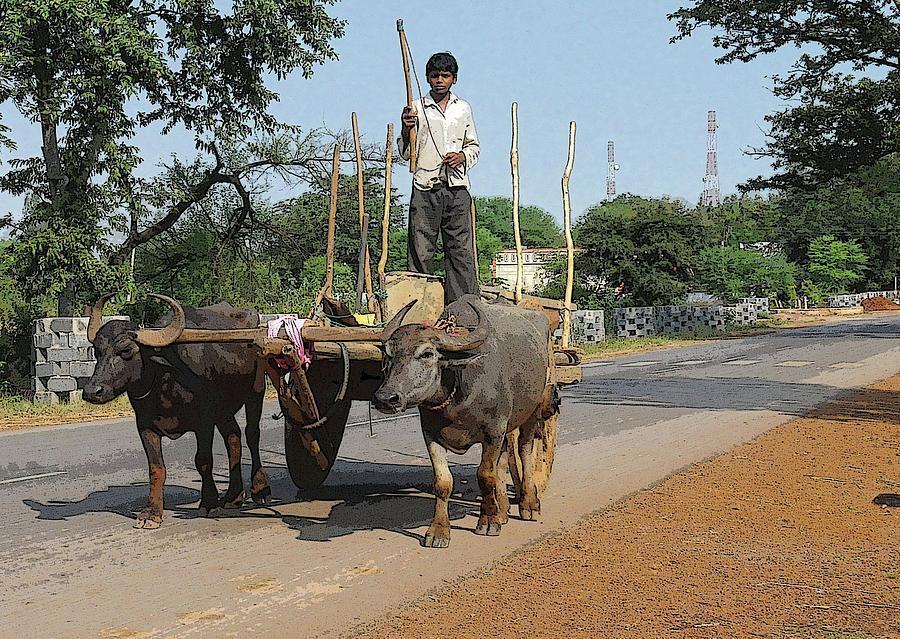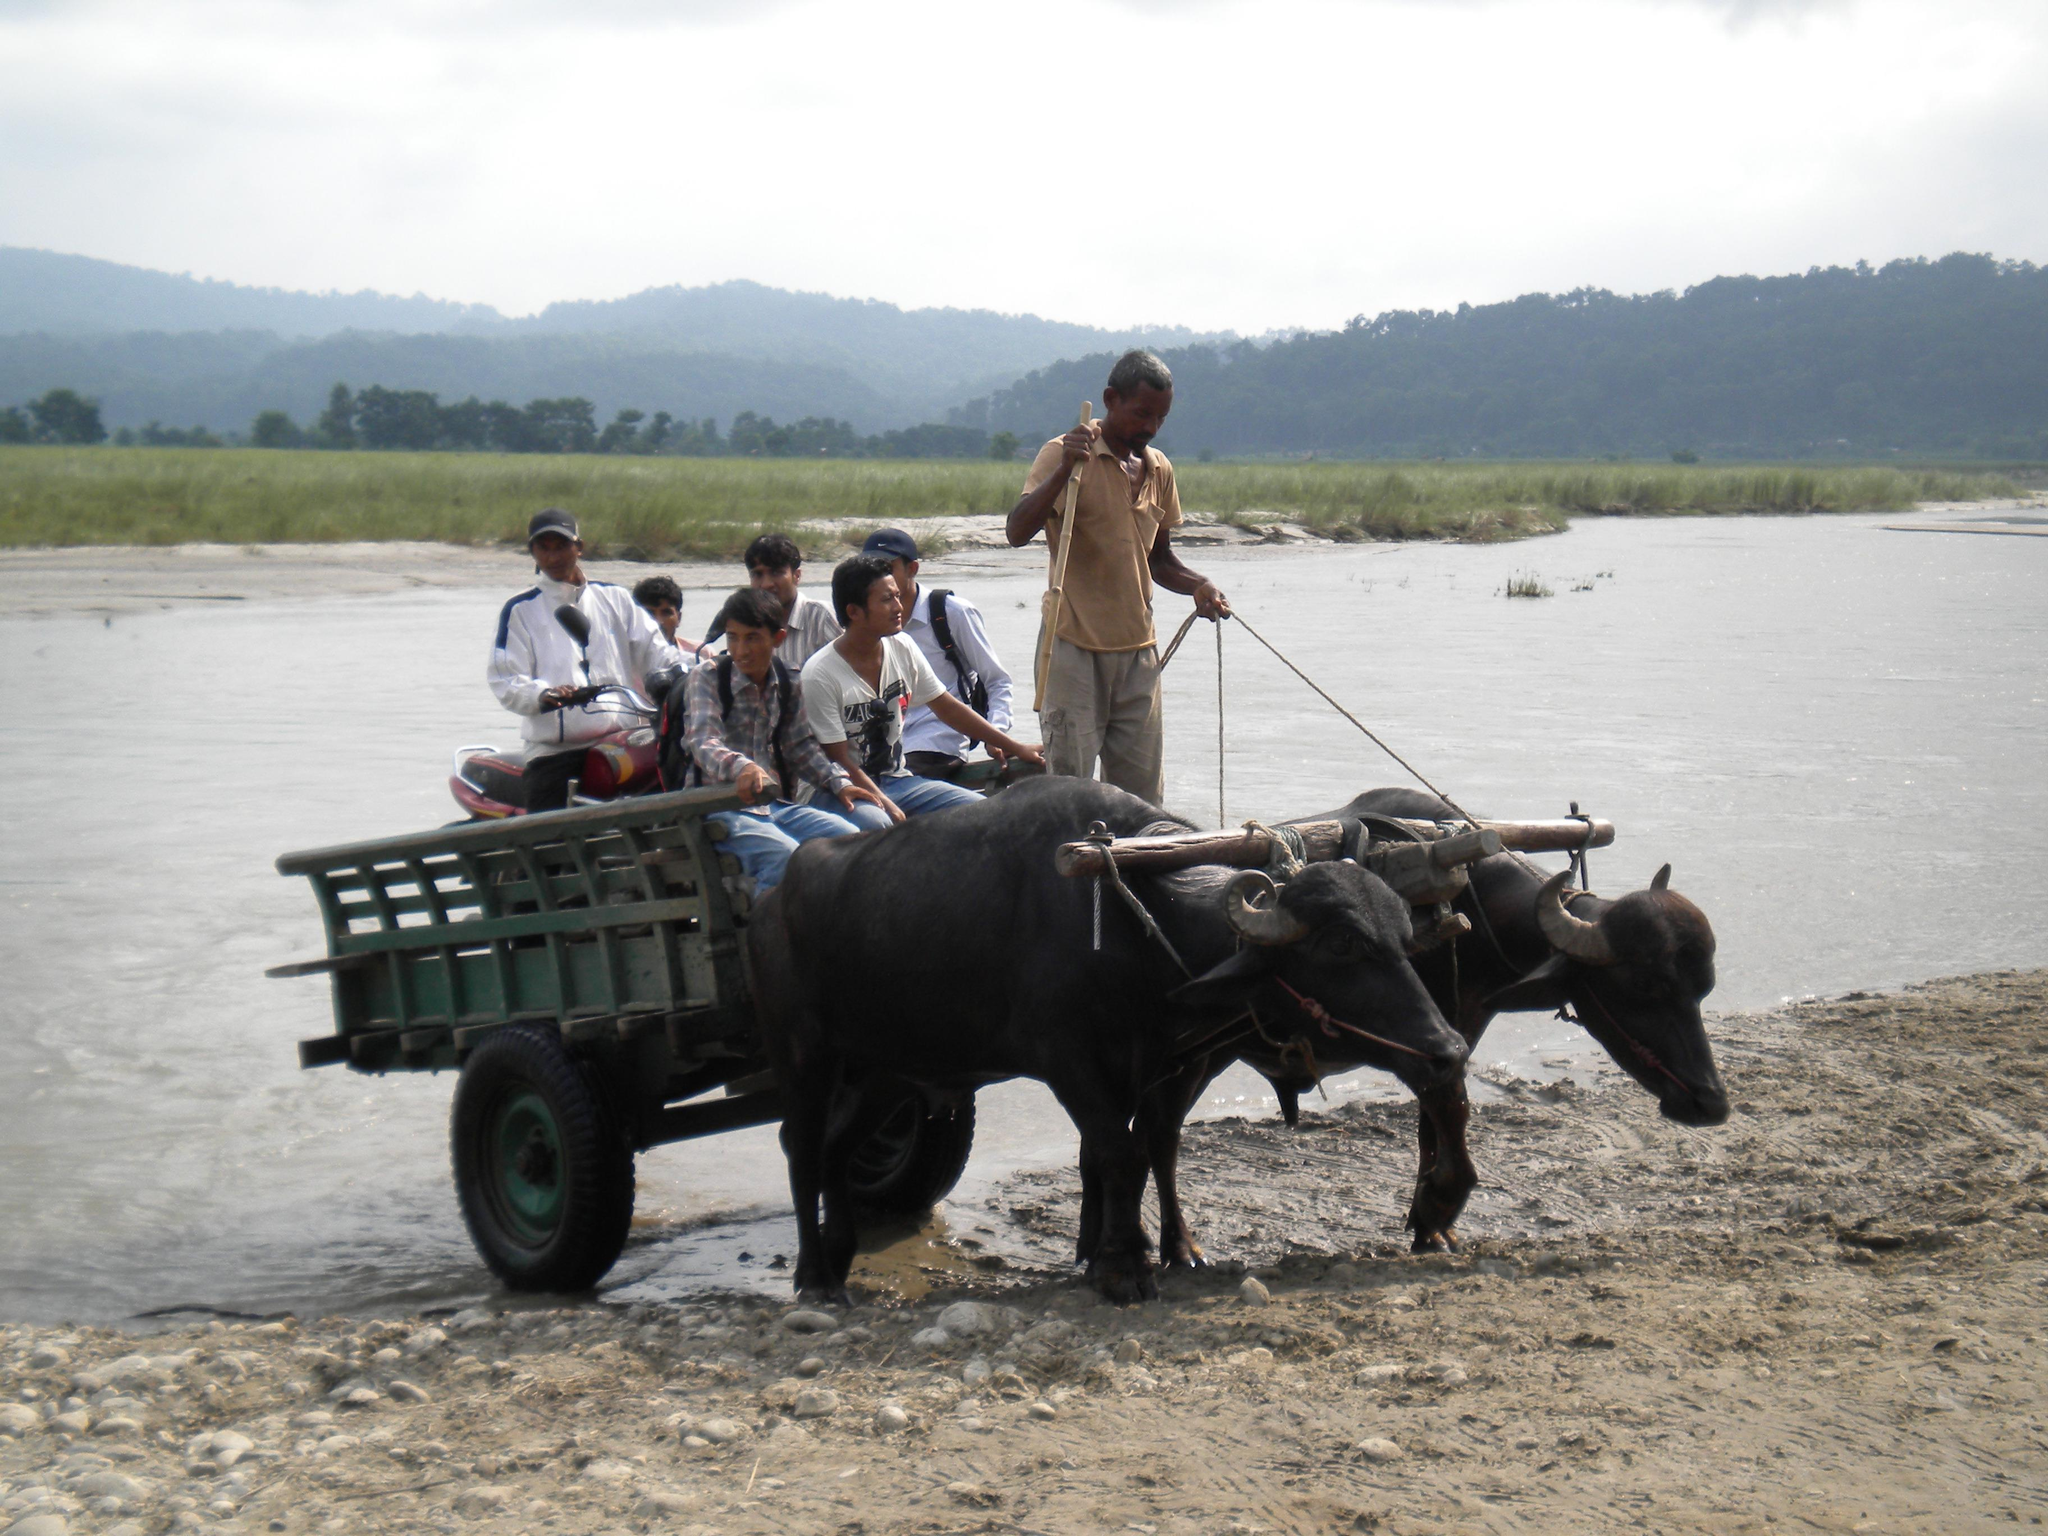The first image is the image on the left, the second image is the image on the right. Given the left and right images, does the statement "At least one water buffalo is standing in water." hold true? Answer yes or no. No. The first image is the image on the left, the second image is the image on the right. Given the left and right images, does the statement "Right image shows one ox with a rope looped through its nose, walking in water." hold true? Answer yes or no. No. 